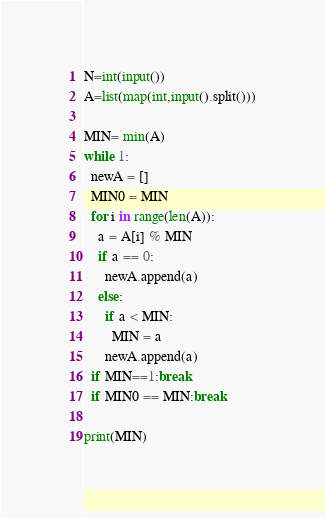<code> <loc_0><loc_0><loc_500><loc_500><_Python_>N=int(input())
A=list(map(int,input().split()))

MIN= min(A)
while 1:
  newA = []
  MIN0 = MIN
  for i in range(len(A)):
    a = A[i] % MIN
    if a == 0:
      newA.append(a)
    else:
      if a < MIN:
        MIN = a
      newA.append(a)
  if MIN==1:break
  if MIN0 == MIN:break

print(MIN)</code> 